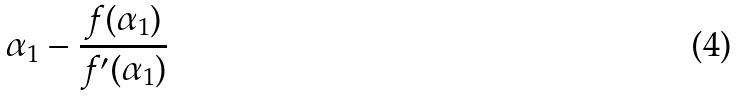Convert formula to latex. <formula><loc_0><loc_0><loc_500><loc_500>\alpha _ { 1 } - \frac { f ( \alpha _ { 1 } ) } { f ^ { \prime } ( \alpha _ { 1 } ) }</formula> 